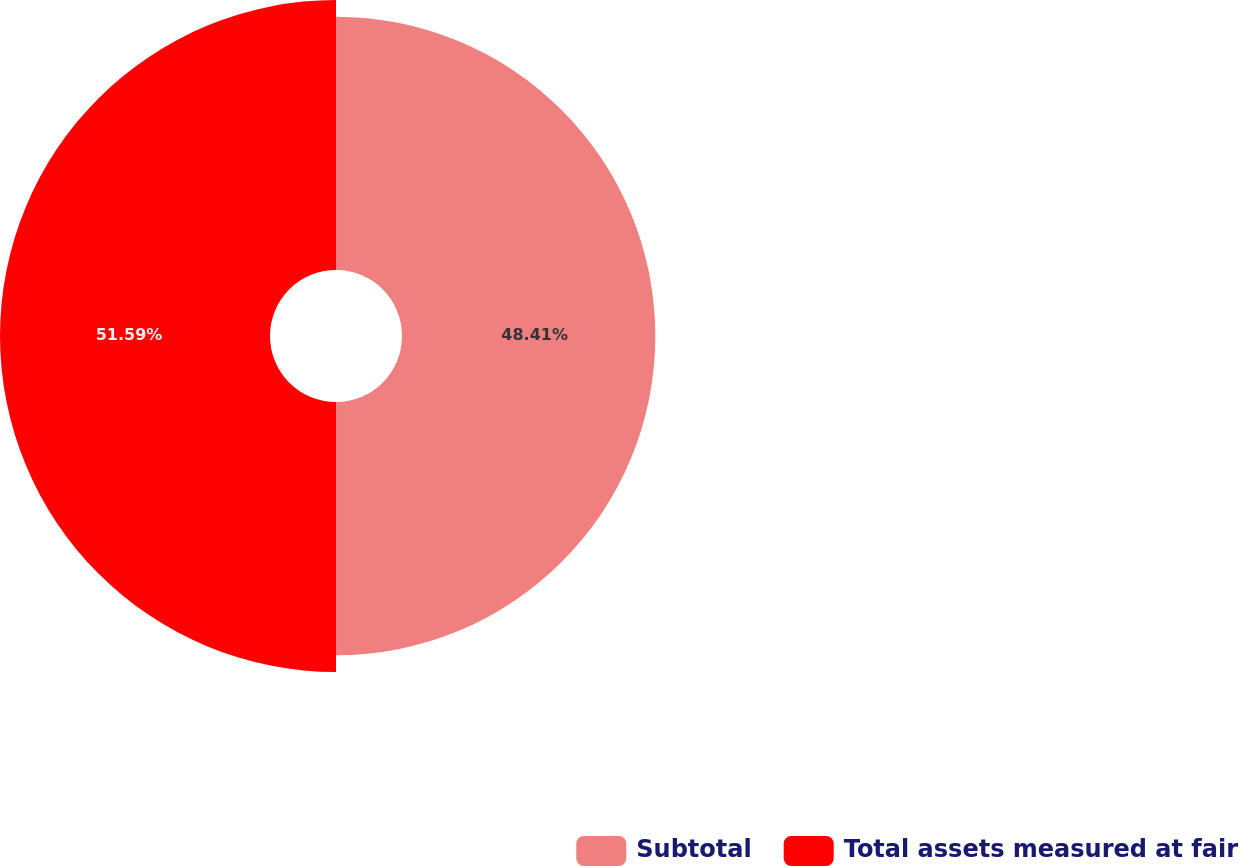Convert chart. <chart><loc_0><loc_0><loc_500><loc_500><pie_chart><fcel>Subtotal<fcel>Total assets measured at fair<nl><fcel>48.41%<fcel>51.59%<nl></chart> 